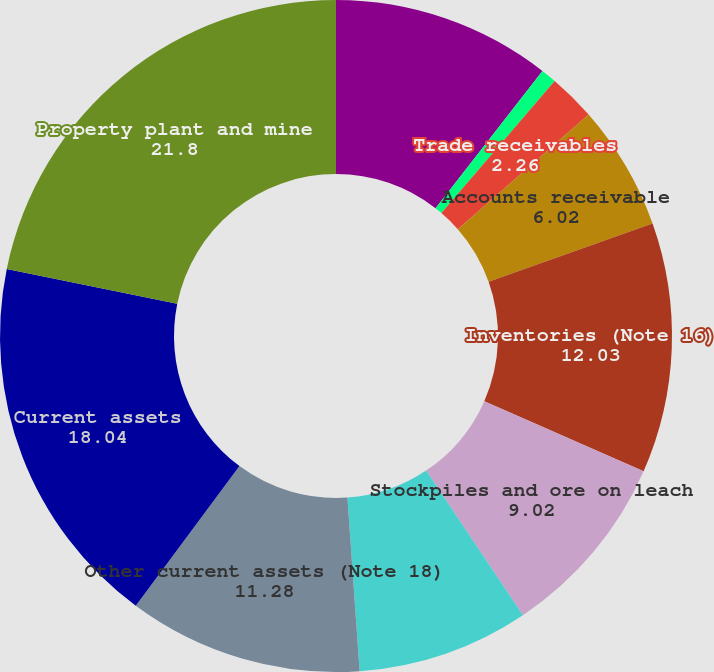<chart> <loc_0><loc_0><loc_500><loc_500><pie_chart><fcel>Cash and cash equivalents<fcel>Marketable securities and<fcel>Trade receivables<fcel>Accounts receivable<fcel>Inventories (Note 16)<fcel>Stockpiles and ore on leach<fcel>Deferred income tax assets<fcel>Other current assets (Note 18)<fcel>Current assets<fcel>Property plant and mine<nl><fcel>10.53%<fcel>0.75%<fcel>2.26%<fcel>6.02%<fcel>12.03%<fcel>9.02%<fcel>8.27%<fcel>11.28%<fcel>18.04%<fcel>21.8%<nl></chart> 